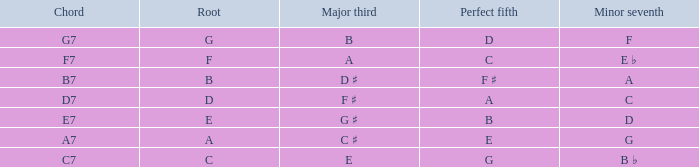What is the chord with a major third of e? C7. 